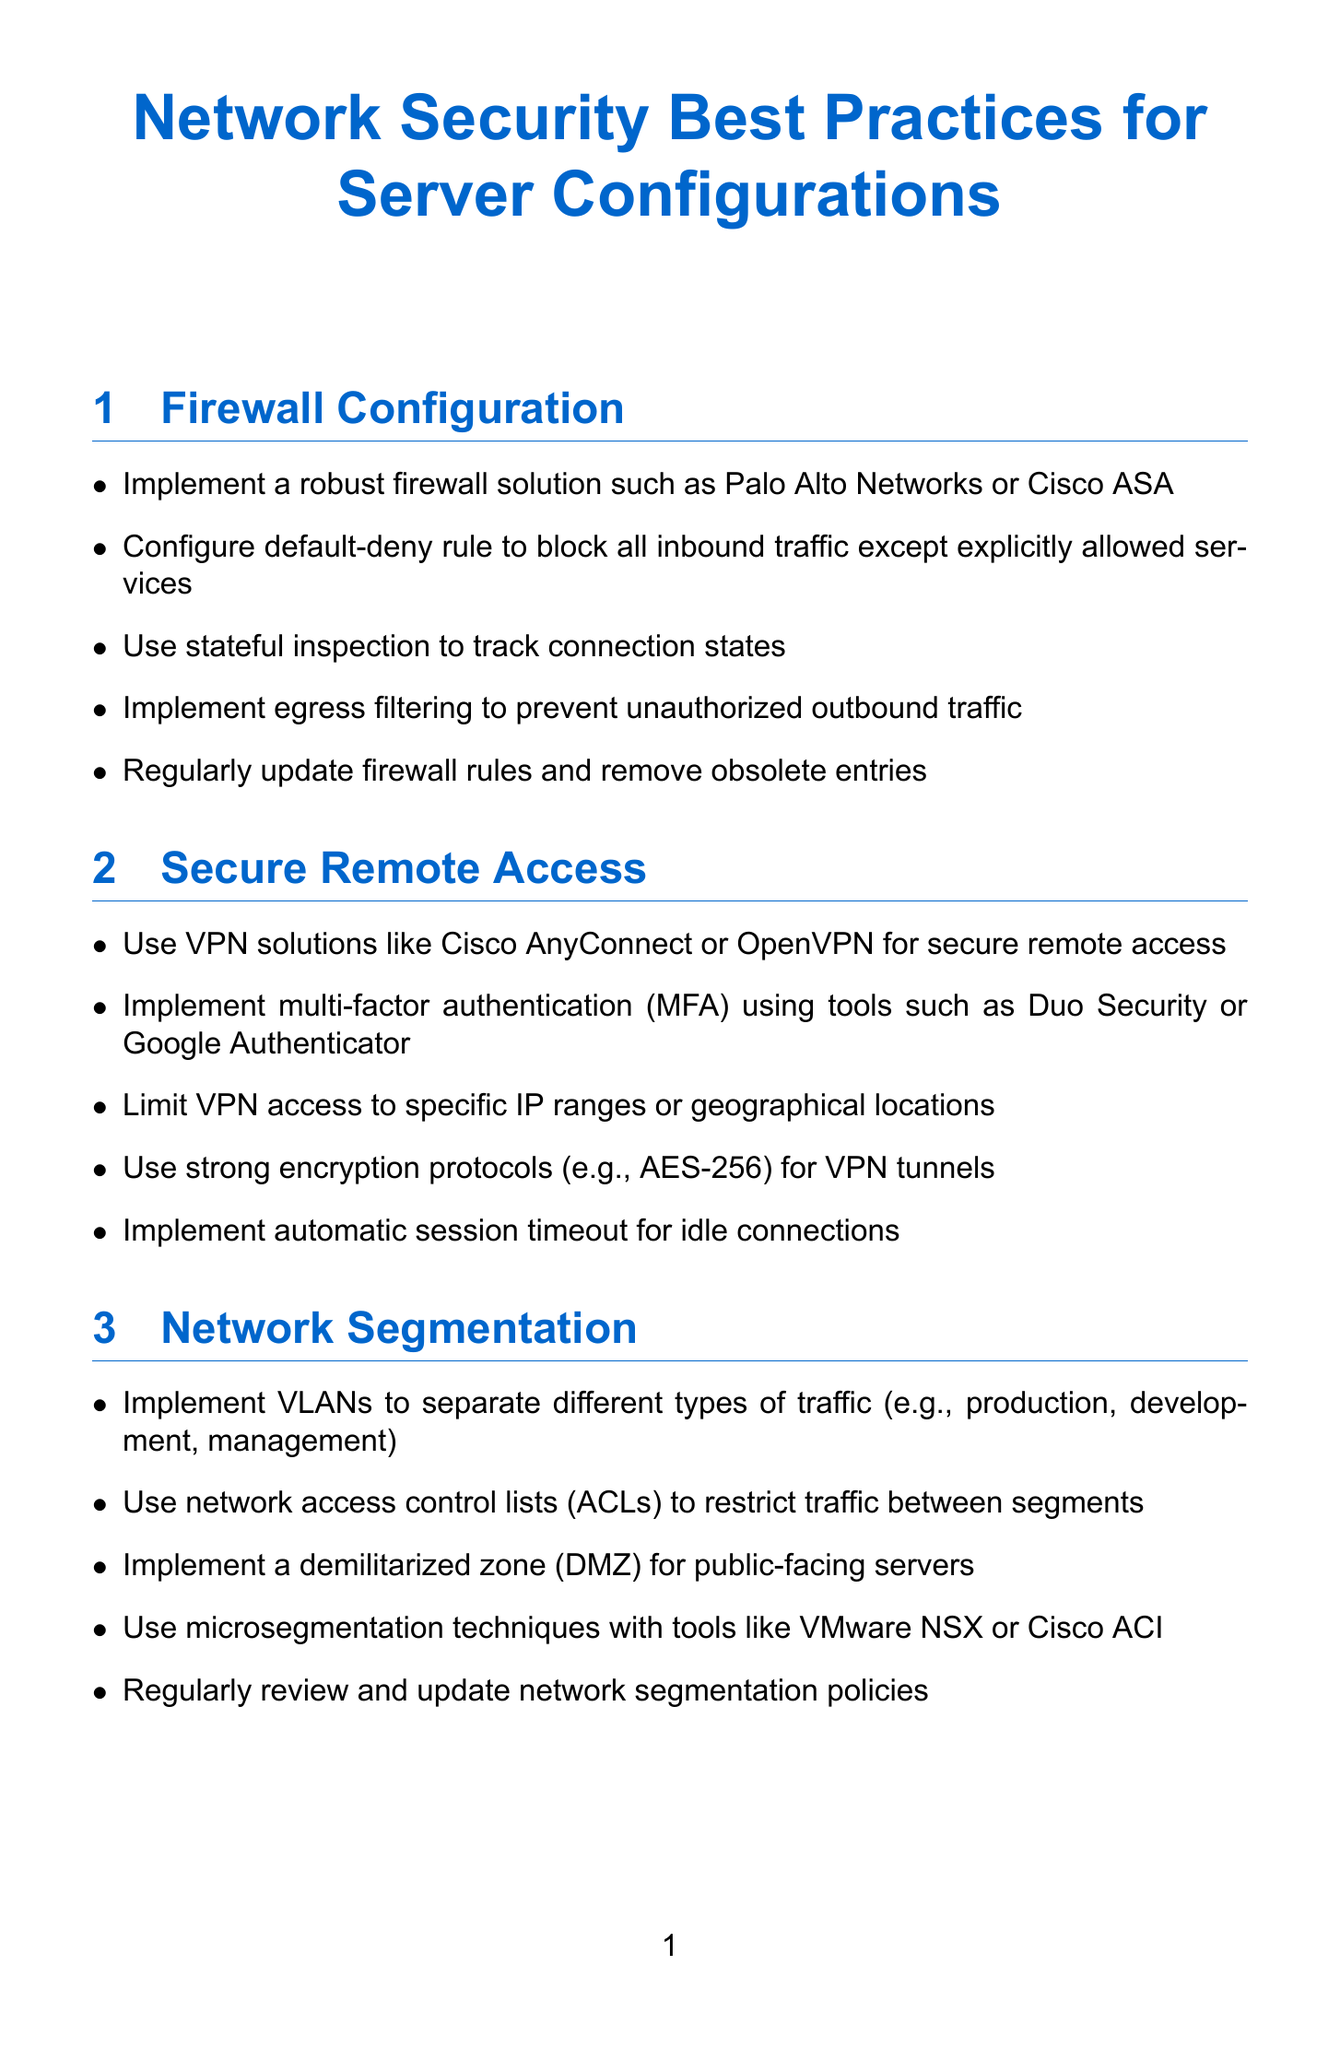What is the title of the manual? The title of the manual is clearly stated at the top of the document.
Answer: Network Security Best Practices for Server Configurations How many sections are in the manual? The manual has a specific number of sections listed sequentially.
Answer: 8 What firewall solution is recommended? The document mentions specific firewall solutions in the Firewall Configuration section.
Answer: Palo Alto Networks or Cisco ASA What is a recommended VPN solution? The section on Secure Remote Access specifies VPN solutions.
Answer: Cisco AnyConnect or OpenVPN What principle should be implemented for user accounts? The Access Control and Authentication section discusses a key principle for account management.
Answer: Principle of least privilege Which tool is suggested for centralized logging? The Logging and Monitoring section suggests specific tools for logging.
Answer: Graylog or Logstash What encryption protocol should be used for VPN tunnels? The Secure Remote Access section specifies encryption protocols for VPN.
Answer: AES-256 What should be regularly updated in the Firewall Configuration? The document highlights an important maintenance task in the Firewall Configuration section.
Answer: Firewall rules 